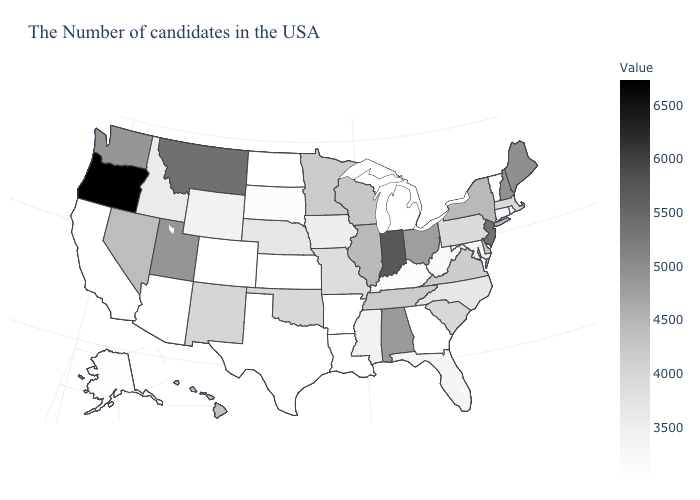Does Pennsylvania have a lower value than Vermont?
Write a very short answer. No. Does Oregon have the highest value in the West?
Quick response, please. Yes. 